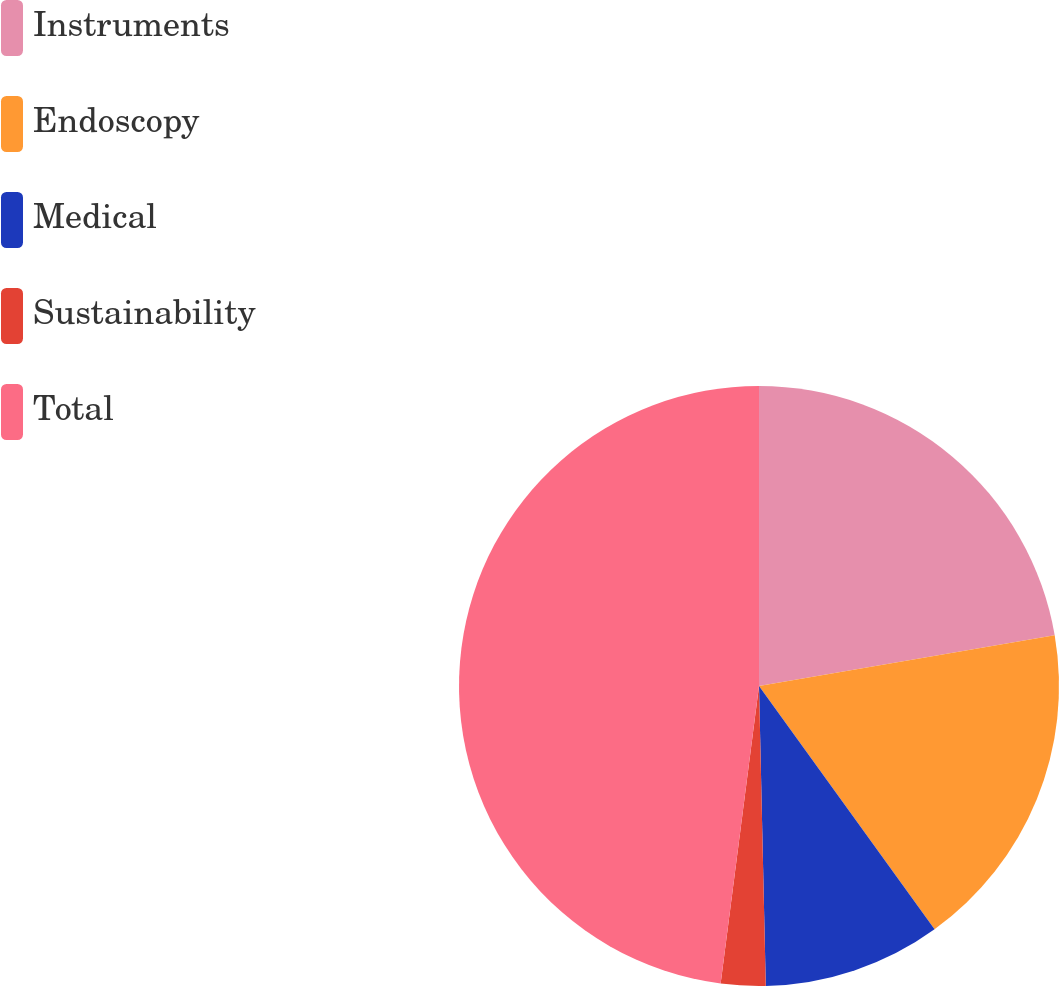<chart> <loc_0><loc_0><loc_500><loc_500><pie_chart><fcel>Instruments<fcel>Endoscopy<fcel>Medical<fcel>Sustainability<fcel>Total<nl><fcel>22.3%<fcel>17.75%<fcel>9.59%<fcel>2.4%<fcel>47.96%<nl></chart> 